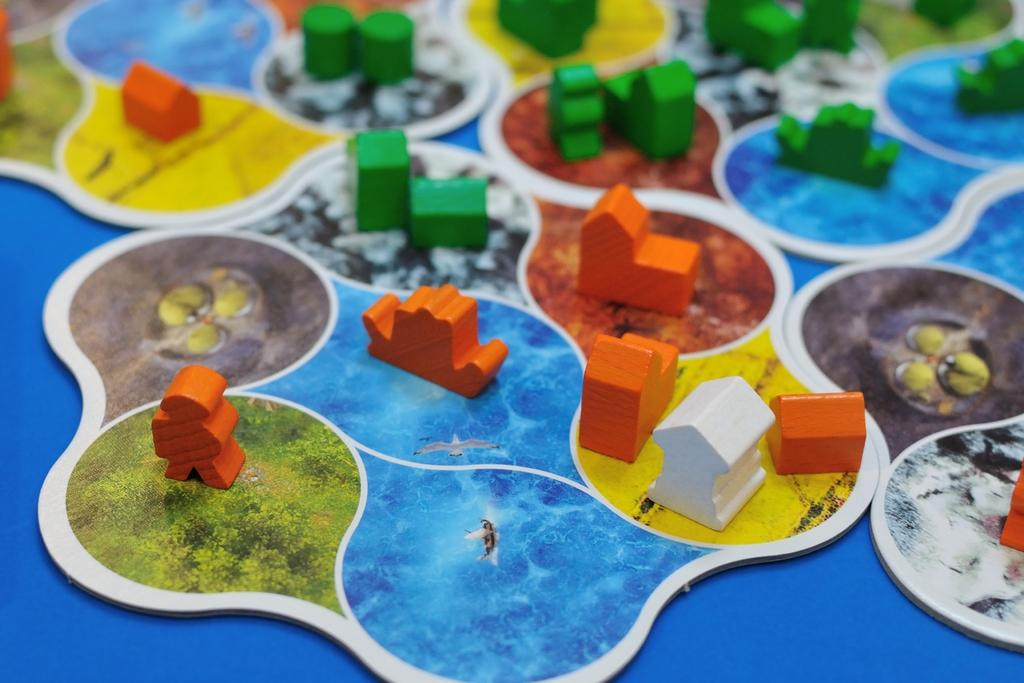What objects are on the cardboard in the image? There are small wooden blocks on the cardboard. Can you describe the design on the cardboard? There is a design on the cardboard, but the specifics are not mentioned in the facts. What colors are the wooden blocks? The wooden blocks are in green, orange, and white colors. What type of beam is holding up the table in the image? There is no table or beam present in the image; it features small wooden blocks on a cardboard with a design. How many balloons are tied to the wooden blocks in the image? There are no balloons present in the image; it only shows wooden blocks on a cardboard with a design. 